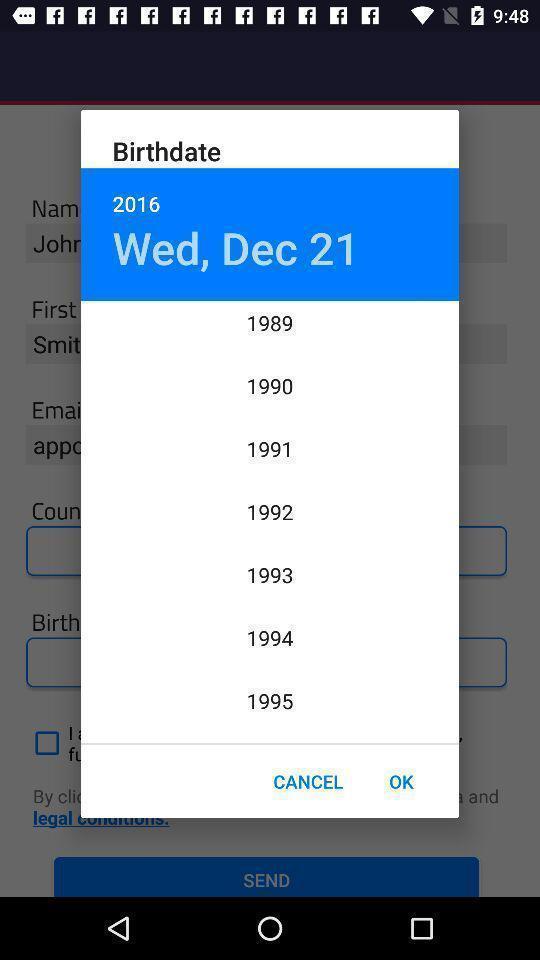Summarize the main components in this picture. Popup showing birthdate and different years on an app. 